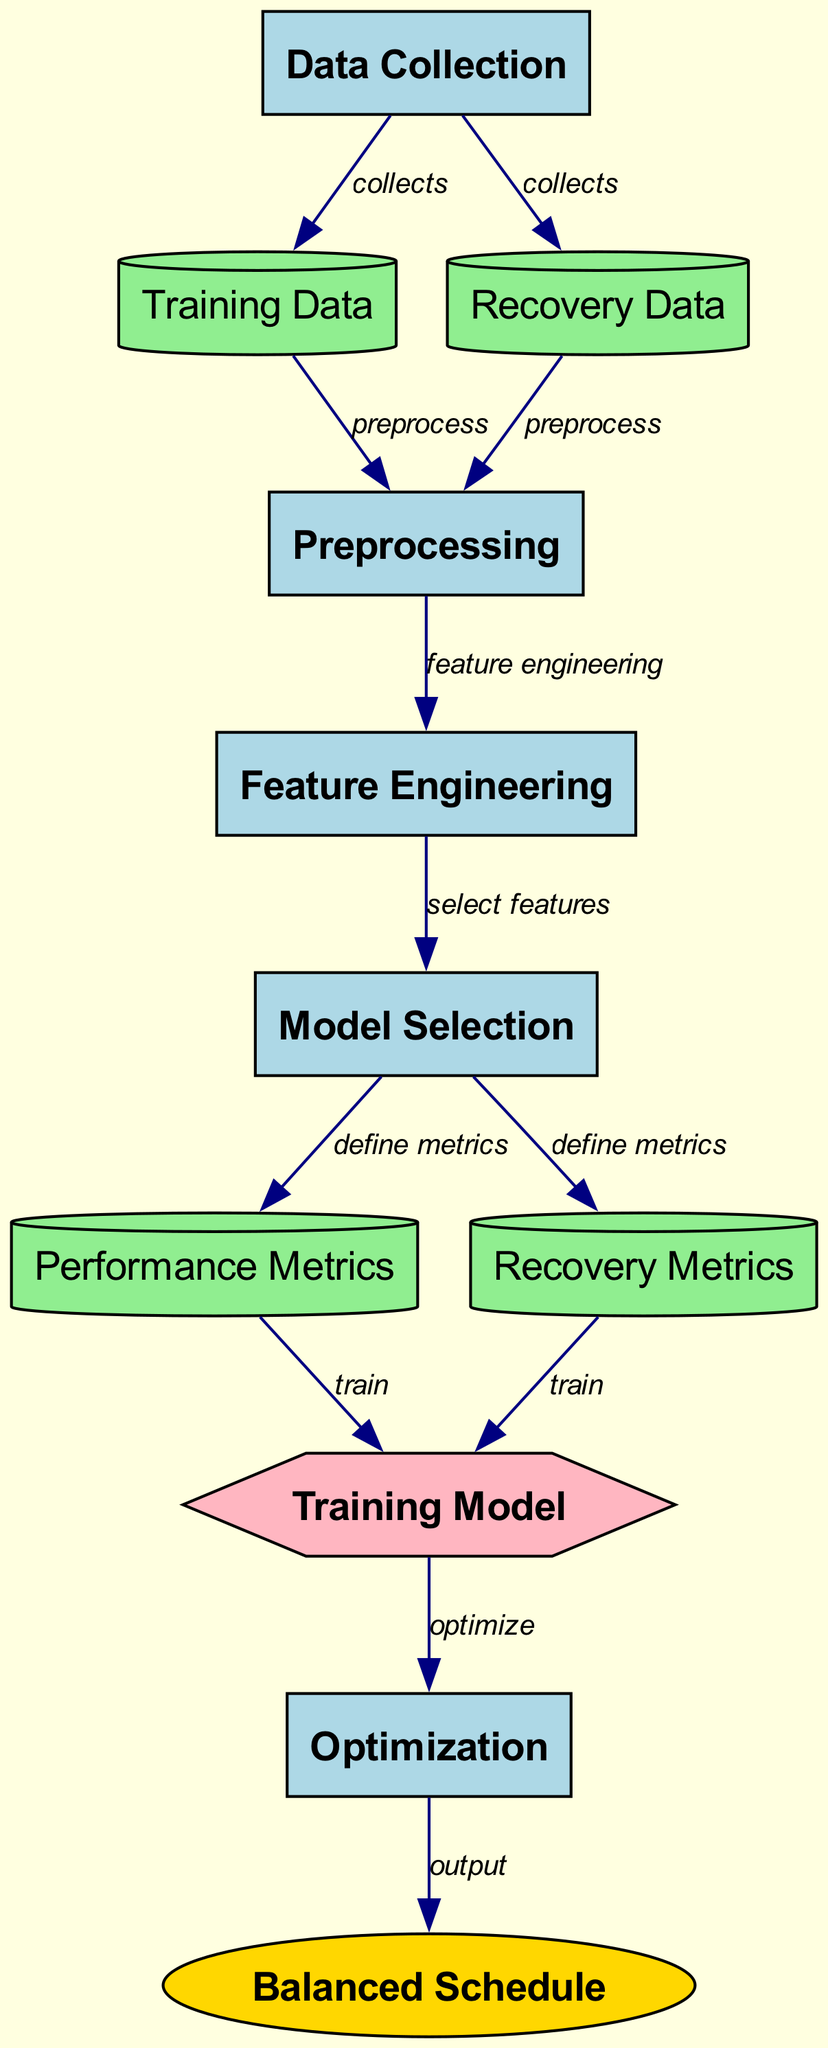What is the first step in the optimization process? The diagram shows that "Data Collection" is the first node, as it collects data and is the starting point of the process flow.
Answer: Data Collection How many types of outputs are shown in the diagram? The diagram indicates one output node, which is "Balanced Schedule," so there is a total of one output type produced at the end of the process.
Answer: One What are the two main types of data being collected? The diagram identifies "Training Data" and "Recovery Data," indicating these are the two main types of data collected in the diagram.
Answer: Training Data and Recovery Data What process follows "Preprocessing"? The diagram illustrates that "Feature Engineering" follows "Preprocessing," indicating the order in the training schedule optimization process.
Answer: Feature Engineering How many total nodes appear in the diagram? By counting each node listed in the diagram, there are ten distinct nodes involved in the machine learning process, including data, processes, model, and output nodes.
Answer: Ten What relationship exists between "Model Selection" and "Performance Metrics"? The diagram shows that "Model Selection" defines the "Performance Metrics," which indicates a direct influence or output from model selection to performance metrics determined within the system.
Answer: Defines What does the "Training Model" receive as inputs? The diagram indicates that "Training Model" receives both "Performance Metrics" and "Recovery Metrics" as inputs needed for training.
Answer: Performance Metrics and Recovery Metrics What is the final outcome of the optimization process? According to the diagram, the final outcome of the process is "Balanced Schedule," which is the ultimate goal of optimization in training schedules.
Answer: Balanced Schedule What two processes come before "Optimization"? The diagram shows that "Training Model" and "Feature Engineering" precede "Optimization," thus being essential steps leading up to the optimization phase.
Answer: Training Model and Feature Engineering Which node is responsible for defining metrics? The node labeled "Model Selection" is responsible for defining both performance and recovery metrics in the optimization diagram.
Answer: Model Selection 